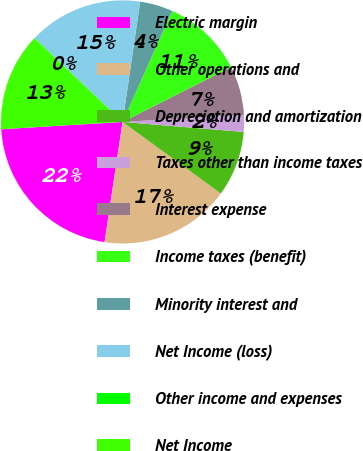Convert chart to OTSL. <chart><loc_0><loc_0><loc_500><loc_500><pie_chart><fcel>Electric margin<fcel>Other operations and<fcel>Depreciation and amortization<fcel>Taxes other than income taxes<fcel>Interest expense<fcel>Income taxes (benefit)<fcel>Minority interest and<fcel>Net Income (loss)<fcel>Other income and expenses<fcel>Net Income<nl><fcel>21.67%<fcel>17.35%<fcel>8.7%<fcel>2.22%<fcel>6.54%<fcel>10.86%<fcel>4.38%<fcel>15.19%<fcel>0.05%<fcel>13.03%<nl></chart> 